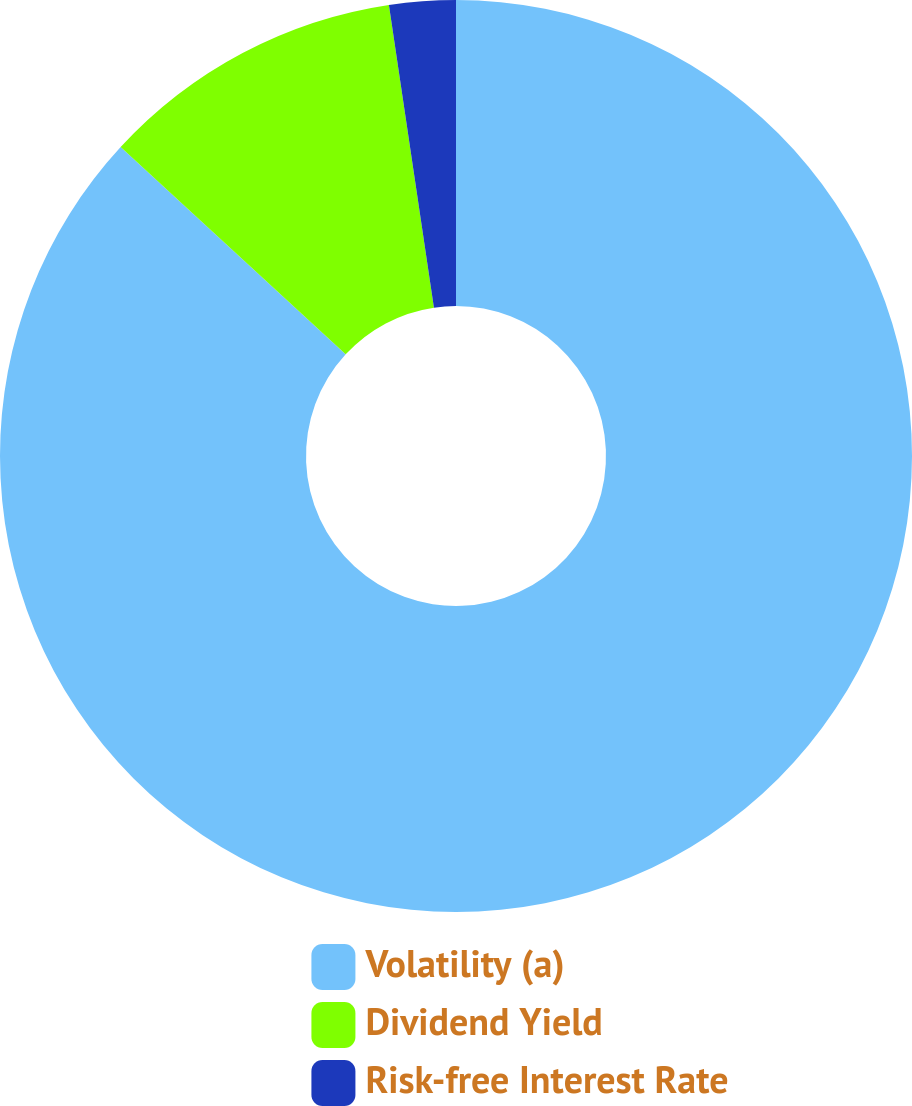Convert chart to OTSL. <chart><loc_0><loc_0><loc_500><loc_500><pie_chart><fcel>Volatility (a)<fcel>Dividend Yield<fcel>Risk-free Interest Rate<nl><fcel>86.84%<fcel>10.8%<fcel>2.35%<nl></chart> 